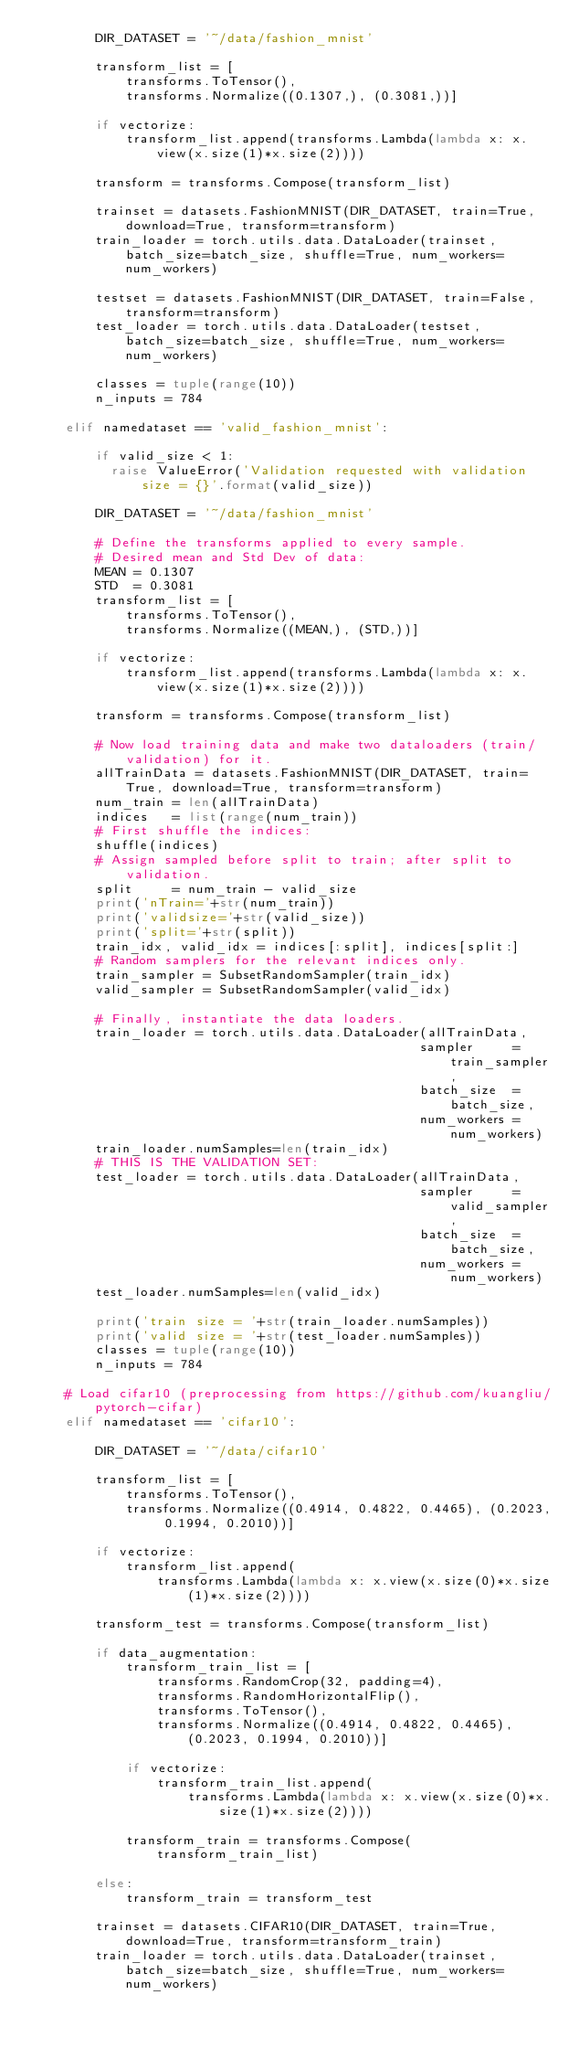Convert code to text. <code><loc_0><loc_0><loc_500><loc_500><_Python_>        DIR_DATASET = '~/data/fashion_mnist'

        transform_list = [
            transforms.ToTensor(),
            transforms.Normalize((0.1307,), (0.3081,))]

        if vectorize:
            transform_list.append(transforms.Lambda(lambda x: x.view(x.size(1)*x.size(2))))

        transform = transforms.Compose(transform_list)

        trainset = datasets.FashionMNIST(DIR_DATASET, train=True, download=True, transform=transform)
        train_loader = torch.utils.data.DataLoader(trainset, batch_size=batch_size, shuffle=True, num_workers=num_workers)

        testset = datasets.FashionMNIST(DIR_DATASET, train=False, transform=transform)
        test_loader = torch.utils.data.DataLoader(testset, batch_size=batch_size, shuffle=True, num_workers=num_workers)

        classes = tuple(range(10))
        n_inputs = 784

    elif namedataset == 'valid_fashion_mnist':

        if valid_size < 1:
          raise ValueError('Validation requested with validation size = {}'.format(valid_size))

        DIR_DATASET = '~/data/fashion_mnist'

        # Define the transforms applied to every sample.
        # Desired mean and Std Dev of data:
        MEAN = 0.1307
        STD  = 0.3081
        transform_list = [
            transforms.ToTensor(),
            transforms.Normalize((MEAN,), (STD,))]

        if vectorize:
            transform_list.append(transforms.Lambda(lambda x: x.view(x.size(1)*x.size(2))))

        transform = transforms.Compose(transform_list)

        # Now load training data and make two dataloaders (train/validation) for it.
        allTrainData = datasets.FashionMNIST(DIR_DATASET, train=True, download=True, transform=transform)
        num_train = len(allTrainData)
        indices   = list(range(num_train))
        # First shuffle the indices:
        shuffle(indices)
        # Assign sampled before split to train; after split to validation.
        split     = num_train - valid_size
        print('nTrain='+str(num_train))
        print('validsize='+str(valid_size))
        print('split='+str(split))
        train_idx, valid_idx = indices[:split], indices[split:]
        # Random samplers for the relevant indices only.
        train_sampler = SubsetRandomSampler(train_idx)
        valid_sampler = SubsetRandomSampler(valid_idx)

        # Finally, instantiate the data loaders.
        train_loader = torch.utils.data.DataLoader(allTrainData,
                                                  sampler     = train_sampler,
                                                  batch_size  = batch_size,
                                                  num_workers = num_workers)
        train_loader.numSamples=len(train_idx)
        # THIS IS THE VALIDATION SET:
        test_loader = torch.utils.data.DataLoader(allTrainData,
                                                  sampler     = valid_sampler,
                                                  batch_size  = batch_size,
                                                  num_workers = num_workers)
        test_loader.numSamples=len(valid_idx)

        print('train size = '+str(train_loader.numSamples))
        print('valid size = '+str(test_loader.numSamples))
        classes = tuple(range(10))
        n_inputs = 784

    # Load cifar10 (preprocessing from https://github.com/kuangliu/pytorch-cifar)
    elif namedataset == 'cifar10':

        DIR_DATASET = '~/data/cifar10'

        transform_list = [
            transforms.ToTensor(),
            transforms.Normalize((0.4914, 0.4822, 0.4465), (0.2023, 0.1994, 0.2010))]

        if vectorize:
            transform_list.append(
                transforms.Lambda(lambda x: x.view(x.size(0)*x.size(1)*x.size(2))))

        transform_test = transforms.Compose(transform_list)

        if data_augmentation:
            transform_train_list = [
                transforms.RandomCrop(32, padding=4),
                transforms.RandomHorizontalFlip(),
                transforms.ToTensor(),
                transforms.Normalize((0.4914, 0.4822, 0.4465), (0.2023, 0.1994, 0.2010))]

            if vectorize:
                transform_train_list.append(
                    transforms.Lambda(lambda x: x.view(x.size(0)*x.size(1)*x.size(2))))

            transform_train = transforms.Compose(transform_train_list)

        else:
            transform_train = transform_test

        trainset = datasets.CIFAR10(DIR_DATASET, train=True, download=True, transform=transform_train)
        train_loader = torch.utils.data.DataLoader(trainset, batch_size=batch_size, shuffle=True, num_workers=num_workers)
</code> 